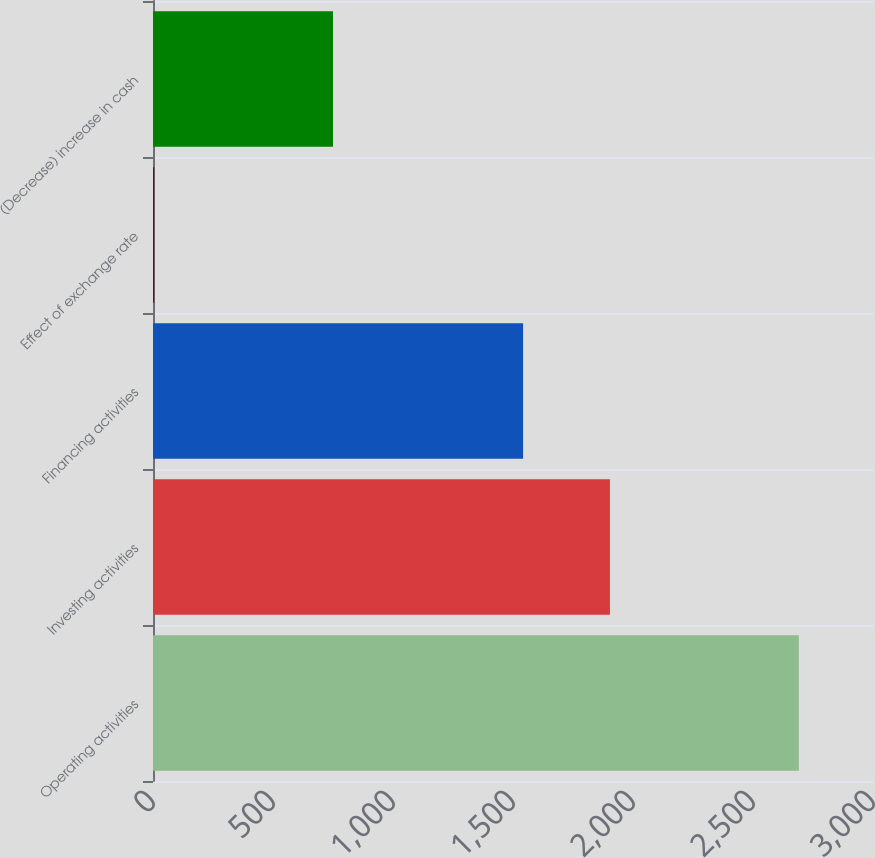Convert chart to OTSL. <chart><loc_0><loc_0><loc_500><loc_500><bar_chart><fcel>Operating activities<fcel>Investing activities<fcel>Financing activities<fcel>Effect of exchange rate<fcel>(Decrease) increase in cash<nl><fcel>2691<fcel>1904<fcel>1542<fcel>5<fcel>750<nl></chart> 